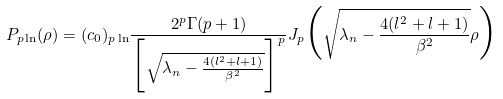Convert formula to latex. <formula><loc_0><loc_0><loc_500><loc_500>P _ { p \ln } ( \rho ) = ( c _ { 0 } ) _ { p \ln } \frac { 2 ^ { p } \Gamma ( p + 1 ) } { \Big { [ } \sqrt { \lambda _ { n } - \frac { 4 ( l ^ { 2 } + l + 1 ) } { \beta ^ { 2 } } } \Big { ] } ^ { p } } J _ { p } \Big { ( } \sqrt { \lambda _ { n } - \frac { 4 ( l ^ { 2 } + l + 1 ) } { \beta ^ { 2 } } } \rho \Big { ) }</formula> 